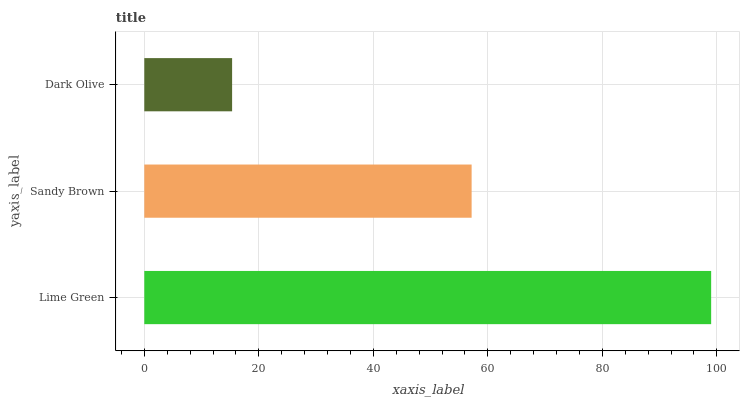Is Dark Olive the minimum?
Answer yes or no. Yes. Is Lime Green the maximum?
Answer yes or no. Yes. Is Sandy Brown the minimum?
Answer yes or no. No. Is Sandy Brown the maximum?
Answer yes or no. No. Is Lime Green greater than Sandy Brown?
Answer yes or no. Yes. Is Sandy Brown less than Lime Green?
Answer yes or no. Yes. Is Sandy Brown greater than Lime Green?
Answer yes or no. No. Is Lime Green less than Sandy Brown?
Answer yes or no. No. Is Sandy Brown the high median?
Answer yes or no. Yes. Is Sandy Brown the low median?
Answer yes or no. Yes. Is Lime Green the high median?
Answer yes or no. No. Is Lime Green the low median?
Answer yes or no. No. 